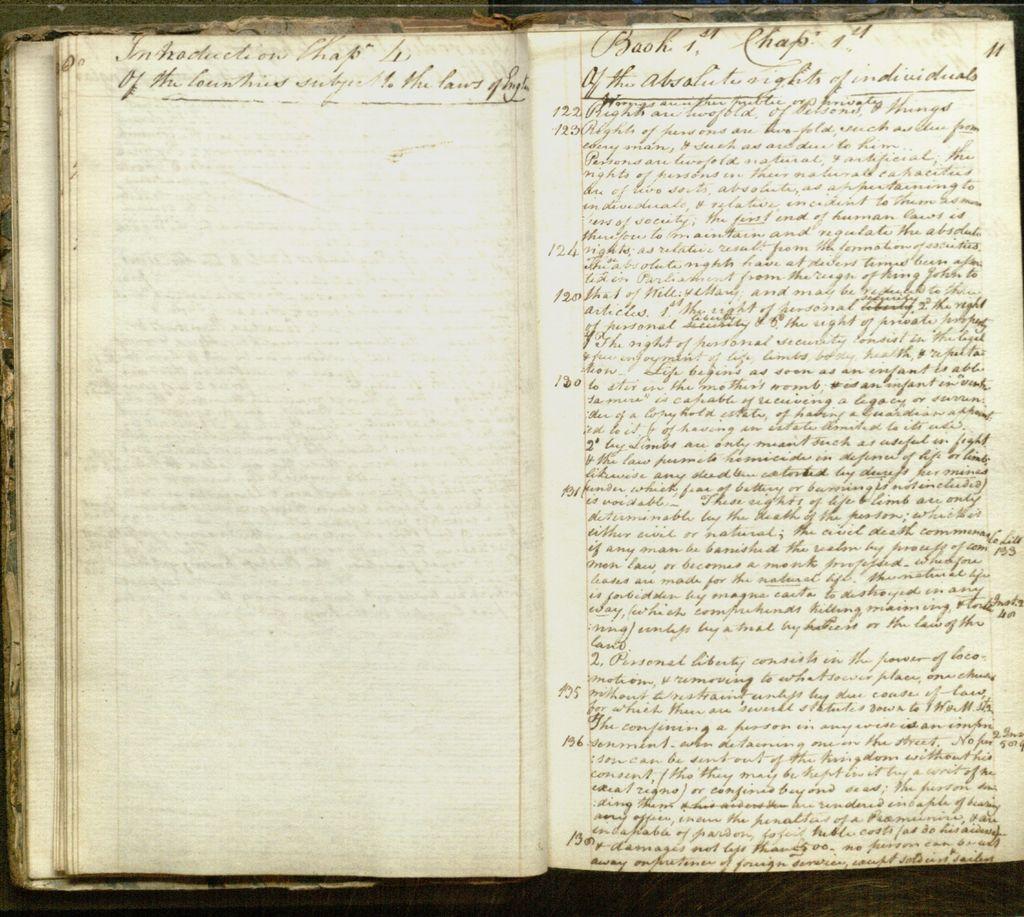What number is written next to the top line on the right?
Your answer should be very brief. 11. This is a diary?
Keep it short and to the point. Yes. 